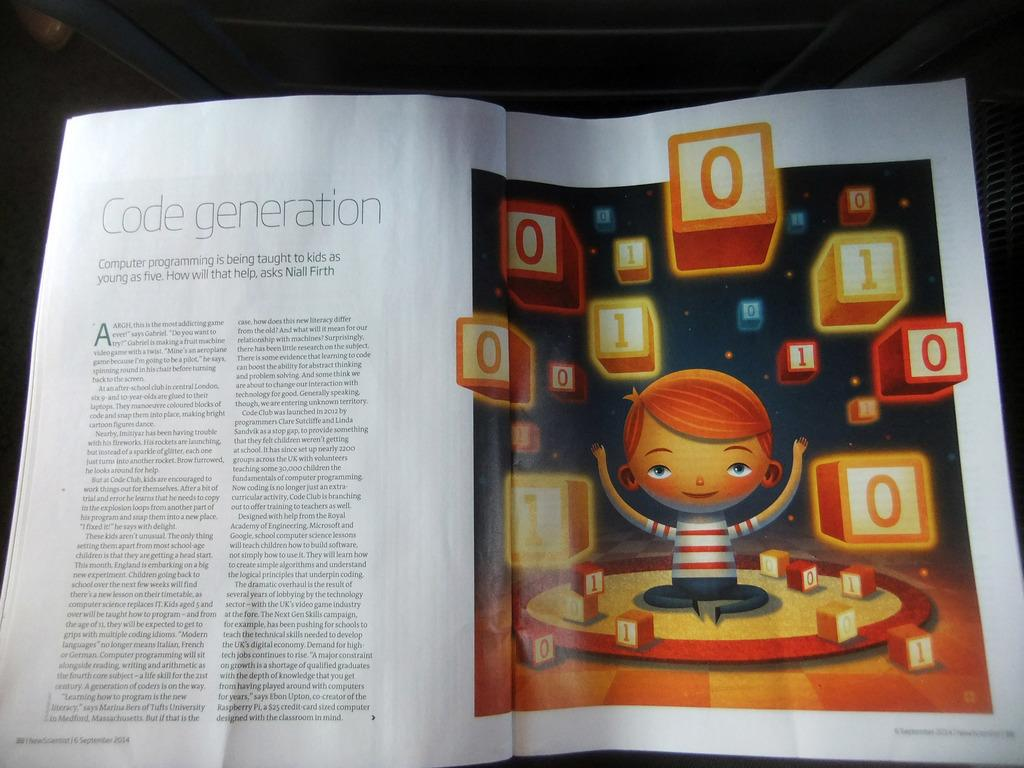<image>
Offer a succinct explanation of the picture presented. A magazine is on a flat surface and is open to an article on computer coding. 